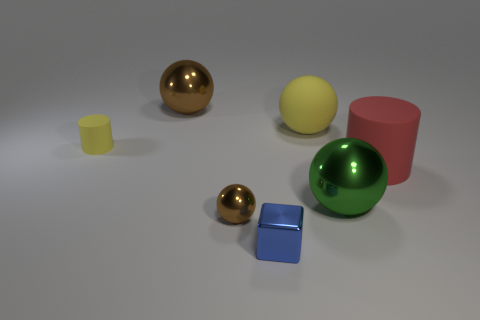Are there any other things that are the same color as the big cylinder?
Offer a very short reply. No. How many small things are balls or yellow things?
Provide a succinct answer. 2. The other large object that is the same material as the large brown object is what shape?
Make the answer very short. Sphere. Are there fewer brown things right of the small blue metal object than green shiny blocks?
Keep it short and to the point. No. Do the small matte thing and the red matte thing have the same shape?
Your answer should be very brief. Yes. How many metal objects are brown cylinders or tiny things?
Provide a succinct answer. 2. Is there a brown metal object that has the same size as the blue shiny cube?
Make the answer very short. Yes. There is a small matte object that is the same color as the matte ball; what shape is it?
Provide a succinct answer. Cylinder. What number of brown things are the same size as the green object?
Your answer should be very brief. 1. There is a brown metallic ball that is right of the big brown thing; is it the same size as the matte object that is left of the blue object?
Keep it short and to the point. Yes. 